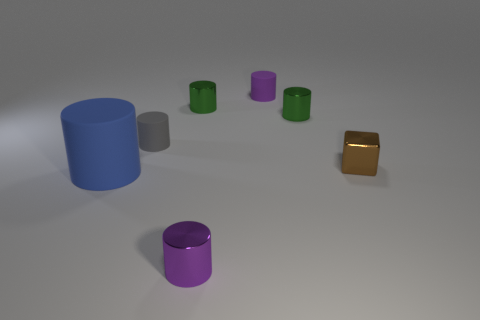The rubber cylinder on the right side of the tiny gray cylinder is what color?
Your response must be concise. Purple. What number of cylinders are either brown rubber things or purple metallic things?
Make the answer very short. 1. How big is the purple cylinder behind the small gray cylinder that is to the left of the cube?
Make the answer very short. Small. Do the big matte object and the small metal object in front of the large blue matte object have the same color?
Keep it short and to the point. No. How many gray cylinders are on the right side of the tiny gray object?
Your answer should be very brief. 0. Is the number of big blue objects less than the number of large brown matte cubes?
Give a very brief answer. No. There is a object that is both to the left of the tiny purple rubber cylinder and behind the tiny gray cylinder; how big is it?
Your answer should be very brief. Small. There is a small metallic object in front of the brown shiny cube; is its color the same as the small block?
Provide a succinct answer. No. Are there fewer tiny rubber objects to the left of the purple metallic thing than big cyan metallic spheres?
Provide a short and direct response. No. What is the shape of the small purple thing that is the same material as the small brown block?
Your answer should be very brief. Cylinder. 